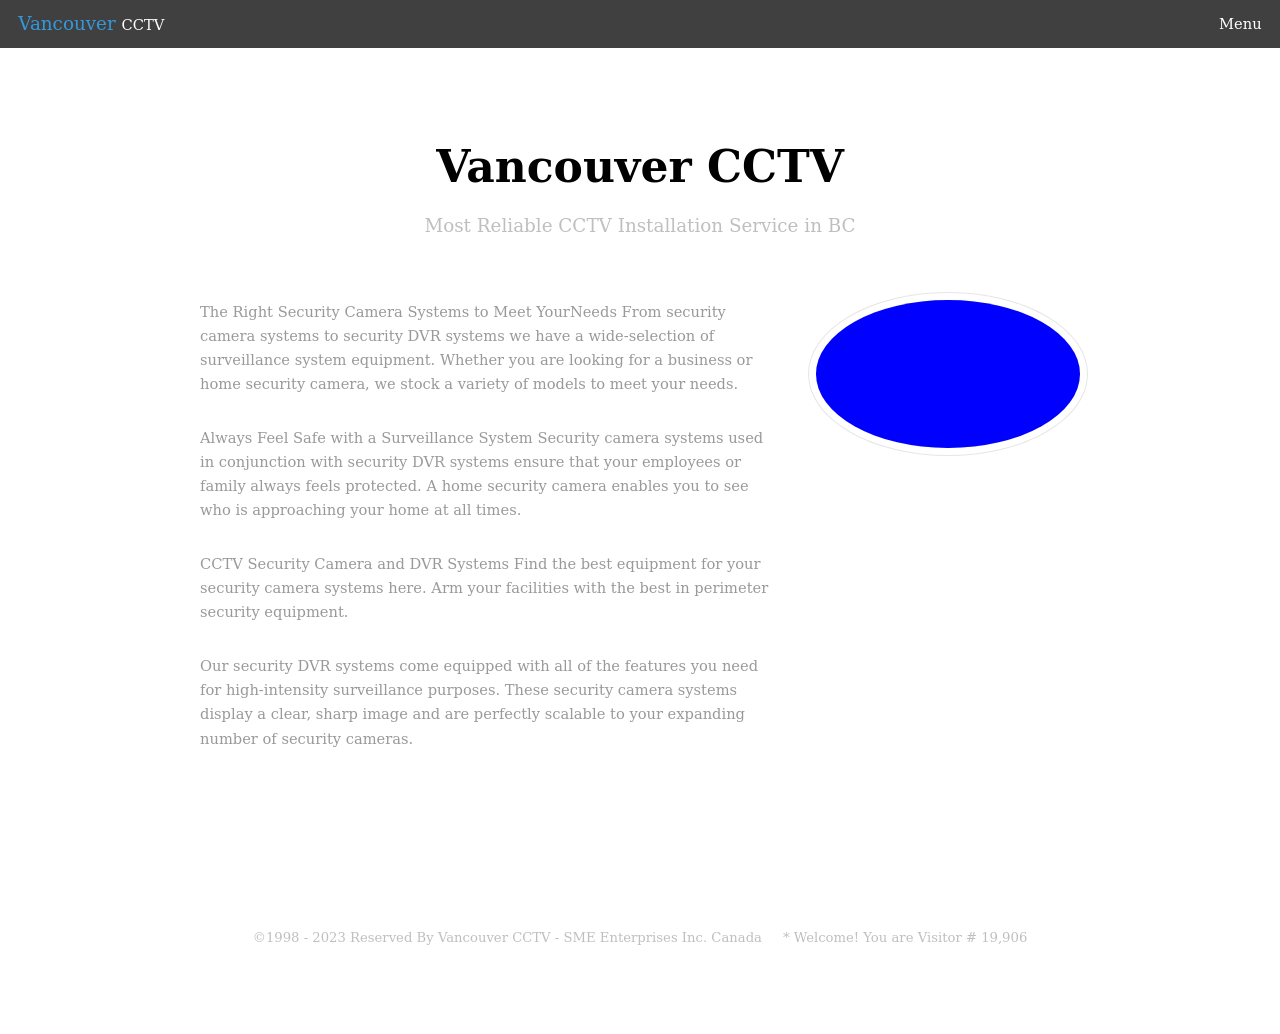What are some key features suggested by the clean and professional design of this website? The design of the website shown suggests several key features that emphasize a professional business service. First, the use of ample white space creates an uncluttered, reader-friendly layout that facilitates easy navigation and readability. Secondly, the monochrome color palette, accentuated with blue for high contrast, conveys reliability and professionalism. Third, the straightforward, centered text arrangement enhances clarity and focus on the essential information. Lastly, the inclusion of detailed service descriptions and business credentials, such as address and contact details, helps build trust and assurance among potential clients. 